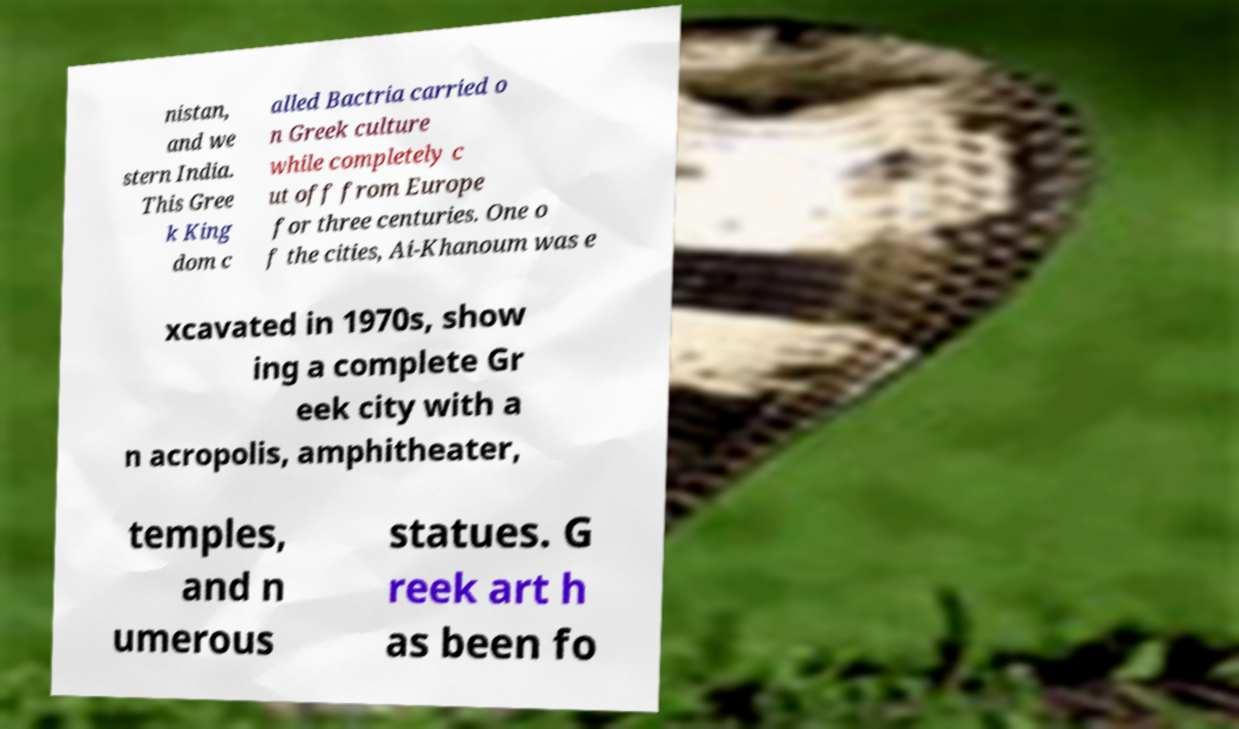Please read and relay the text visible in this image. What does it say? nistan, and we stern India. This Gree k King dom c alled Bactria carried o n Greek culture while completely c ut off from Europe for three centuries. One o f the cities, Ai-Khanoum was e xcavated in 1970s, show ing a complete Gr eek city with a n acropolis, amphitheater, temples, and n umerous statues. G reek art h as been fo 